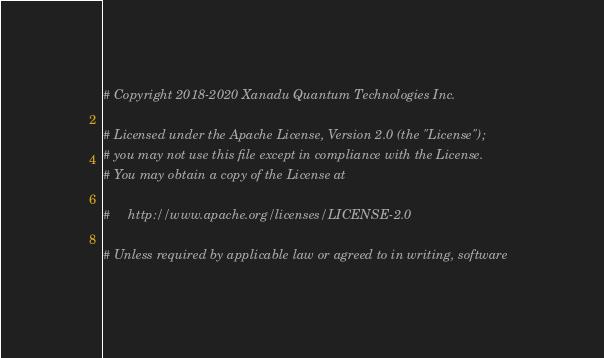Convert code to text. <code><loc_0><loc_0><loc_500><loc_500><_Python_># Copyright 2018-2020 Xanadu Quantum Technologies Inc.

# Licensed under the Apache License, Version 2.0 (the "License");
# you may not use this file except in compliance with the License.
# You may obtain a copy of the License at

#     http://www.apache.org/licenses/LICENSE-2.0

# Unless required by applicable law or agreed to in writing, software</code> 